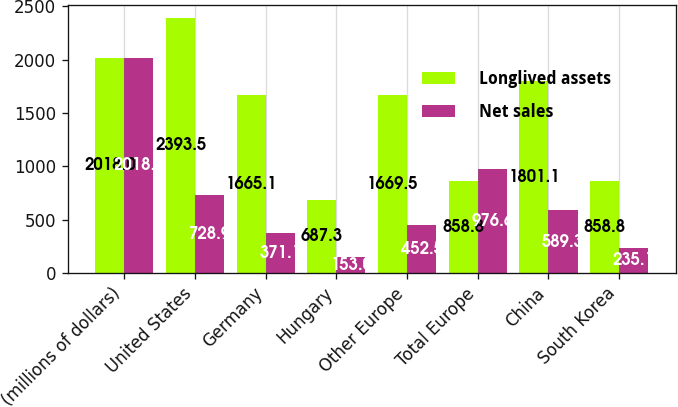<chart> <loc_0><loc_0><loc_500><loc_500><stacked_bar_chart><ecel><fcel>(millions of dollars)<fcel>United States<fcel>Germany<fcel>Hungary<fcel>Other Europe<fcel>Total Europe<fcel>China<fcel>South Korea<nl><fcel>Longlived assets<fcel>2018<fcel>2393.5<fcel>1665.1<fcel>687.3<fcel>1669.5<fcel>858.8<fcel>1801.1<fcel>858.8<nl><fcel>Net sales<fcel>2018<fcel>728.9<fcel>371.1<fcel>153<fcel>452.5<fcel>976.6<fcel>589.3<fcel>235.1<nl></chart> 